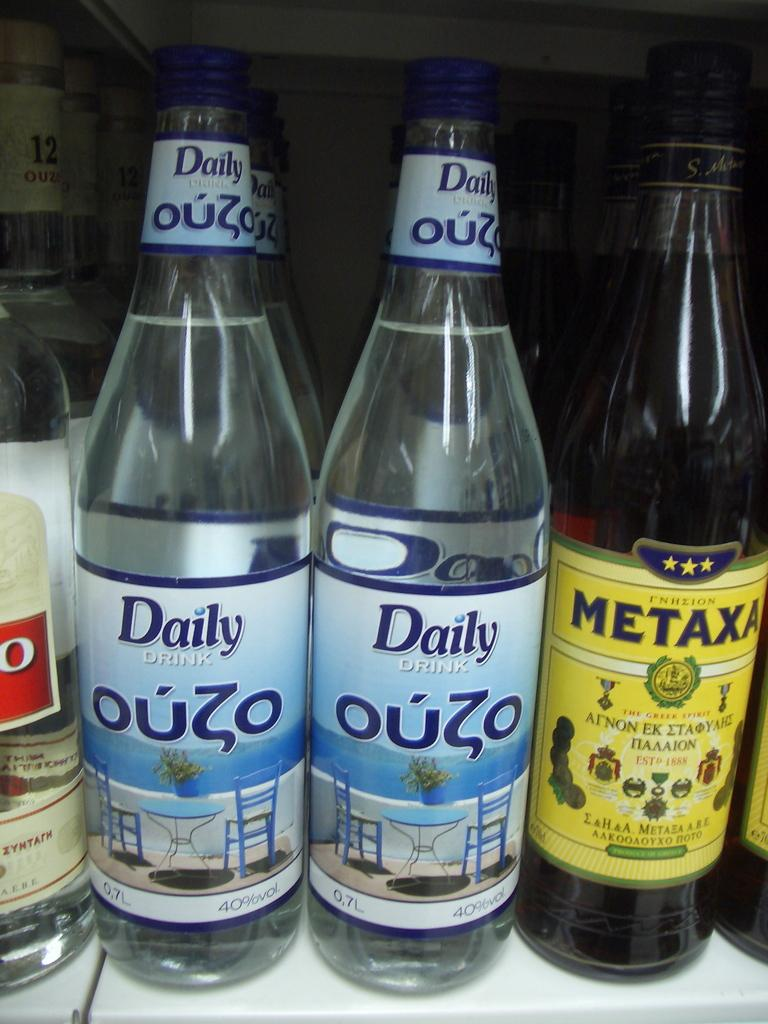<image>
Relay a brief, clear account of the picture shown. Several bottles of Ouzo and Metaxa are sitting on a shelf. 